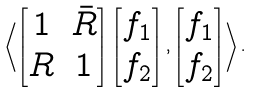Convert formula to latex. <formula><loc_0><loc_0><loc_500><loc_500>\left \langle \begin{bmatrix} 1 & \bar { R } \\ R & 1 \end{bmatrix} \begin{bmatrix} f _ { 1 } \\ f _ { 2 } \end{bmatrix} , \begin{bmatrix} f _ { 1 } \\ f _ { 2 } \end{bmatrix} \right \rangle .</formula> 